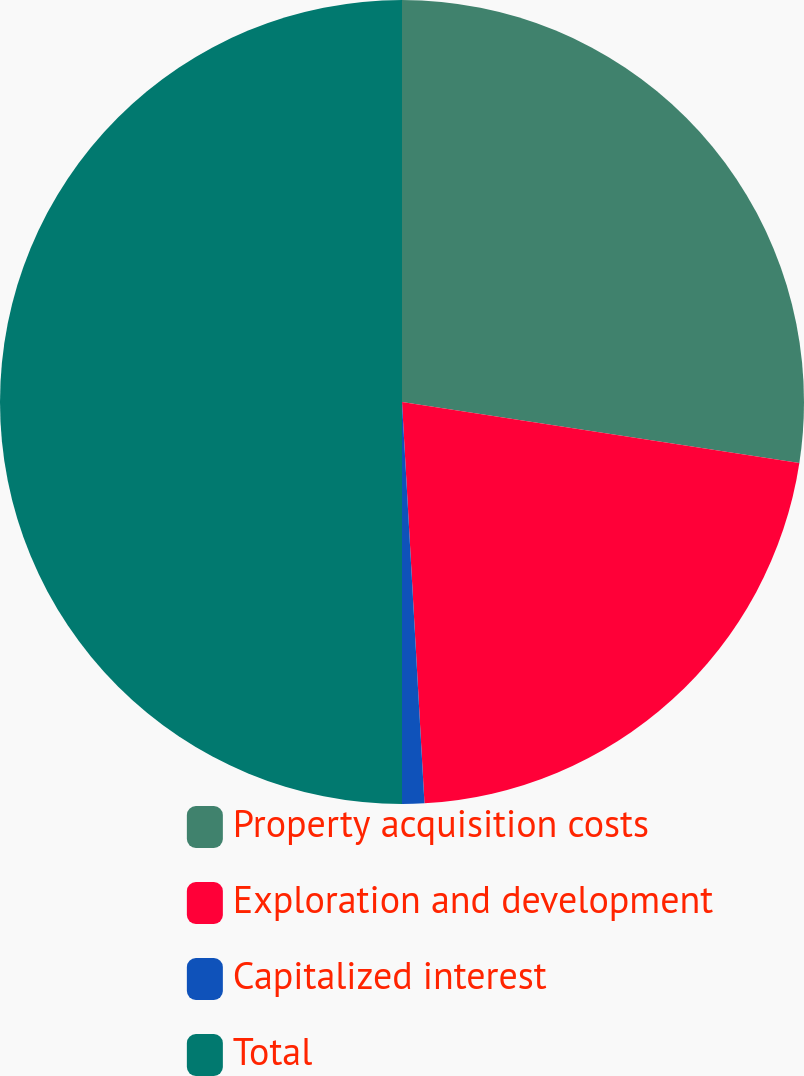Convert chart. <chart><loc_0><loc_0><loc_500><loc_500><pie_chart><fcel>Property acquisition costs<fcel>Exploration and development<fcel>Capitalized interest<fcel>Total<nl><fcel>27.42%<fcel>21.69%<fcel>0.89%<fcel>50.0%<nl></chart> 